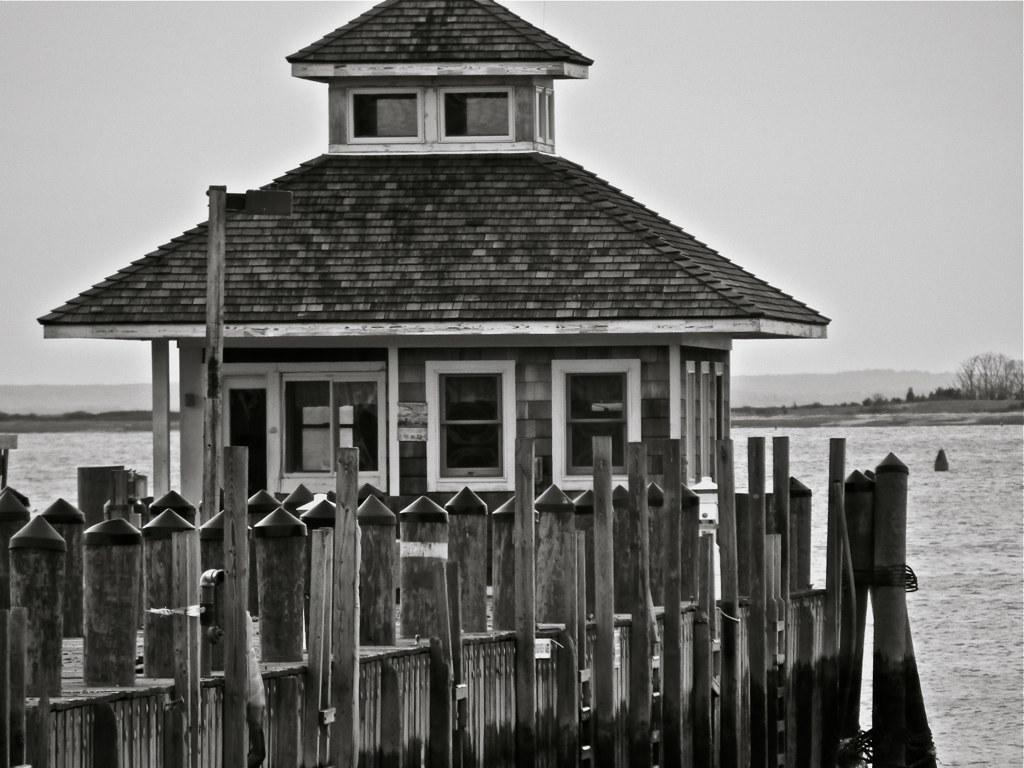In one or two sentences, can you explain what this image depicts? On the left side, there is a building having roofs and glass windows and there is a fence. In the background, there is water, there are trees, there are mountains and there are clouds in the sky. 